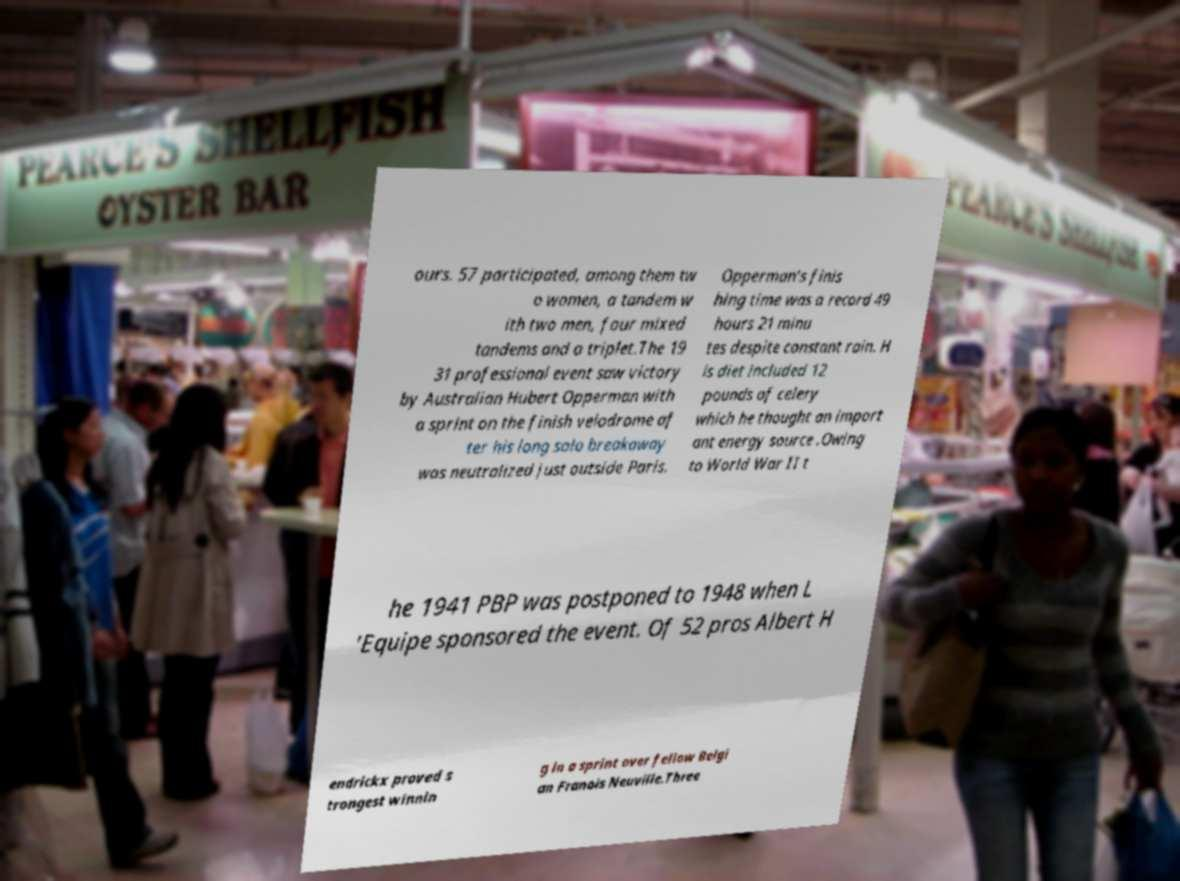Can you read and provide the text displayed in the image?This photo seems to have some interesting text. Can you extract and type it out for me? ours. 57 participated, among them tw o women, a tandem w ith two men, four mixed tandems and a triplet.The 19 31 professional event saw victory by Australian Hubert Opperman with a sprint on the finish velodrome af ter his long solo breakaway was neutralized just outside Paris. Opperman's finis hing time was a record 49 hours 21 minu tes despite constant rain. H is diet included 12 pounds of celery which he thought an import ant energy source .Owing to World War II t he 1941 PBP was postponed to 1948 when L 'Equipe sponsored the event. Of 52 pros Albert H endrickx proved s trongest winnin g in a sprint over fellow Belgi an Franois Neuville.Three 